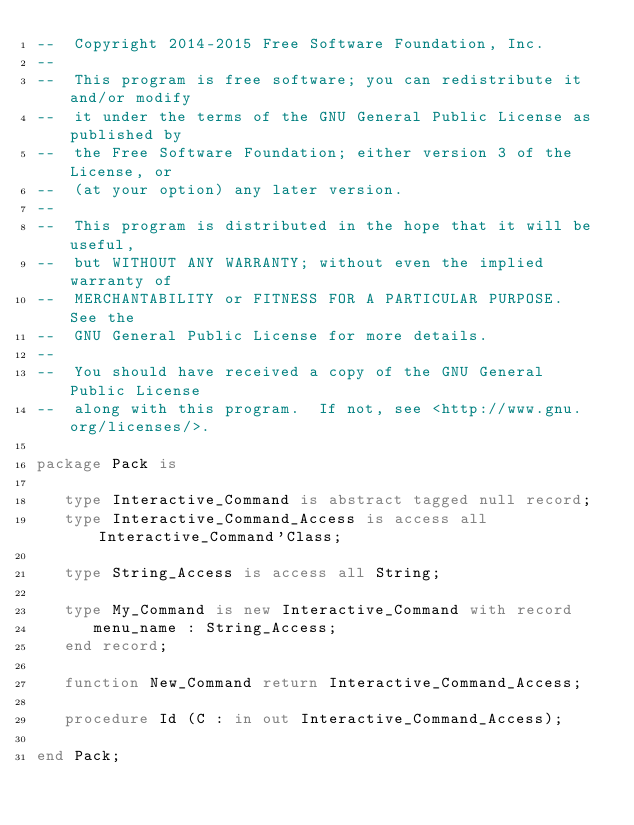<code> <loc_0><loc_0><loc_500><loc_500><_Ada_>--  Copyright 2014-2015 Free Software Foundation, Inc.
--
--  This program is free software; you can redistribute it and/or modify
--  it under the terms of the GNU General Public License as published by
--  the Free Software Foundation; either version 3 of the License, or
--  (at your option) any later version.
--
--  This program is distributed in the hope that it will be useful,
--  but WITHOUT ANY WARRANTY; without even the implied warranty of
--  MERCHANTABILITY or FITNESS FOR A PARTICULAR PURPOSE.  See the
--  GNU General Public License for more details.
--
--  You should have received a copy of the GNU General Public License
--  along with this program.  If not, see <http://www.gnu.org/licenses/>.

package Pack is

   type Interactive_Command is abstract tagged null record;
   type Interactive_Command_Access is access all Interactive_Command'Class;

   type String_Access is access all String;

   type My_Command is new Interactive_Command with record
      menu_name : String_Access;
   end record;

   function New_Command return Interactive_Command_Access;

   procedure Id (C : in out Interactive_Command_Access);

end Pack;
</code> 